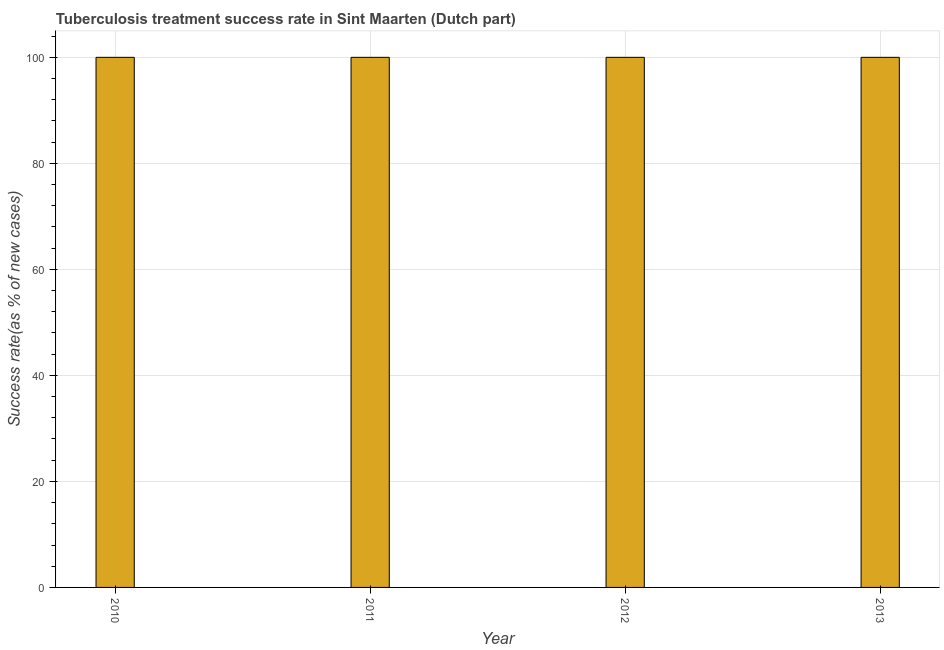Does the graph contain grids?
Offer a very short reply. Yes. What is the title of the graph?
Provide a succinct answer. Tuberculosis treatment success rate in Sint Maarten (Dutch part). What is the label or title of the Y-axis?
Keep it short and to the point. Success rate(as % of new cases). Across all years, what is the maximum tuberculosis treatment success rate?
Provide a short and direct response. 100. Across all years, what is the minimum tuberculosis treatment success rate?
Your answer should be very brief. 100. In which year was the tuberculosis treatment success rate minimum?
Provide a short and direct response. 2010. What is the difference between the tuberculosis treatment success rate in 2010 and 2011?
Your response must be concise. 0. What is the ratio of the tuberculosis treatment success rate in 2010 to that in 2011?
Keep it short and to the point. 1. What is the difference between the highest and the second highest tuberculosis treatment success rate?
Make the answer very short. 0. Is the sum of the tuberculosis treatment success rate in 2012 and 2013 greater than the maximum tuberculosis treatment success rate across all years?
Provide a succinct answer. Yes. How many years are there in the graph?
Offer a very short reply. 4. What is the difference between two consecutive major ticks on the Y-axis?
Your answer should be very brief. 20. Are the values on the major ticks of Y-axis written in scientific E-notation?
Your answer should be compact. No. What is the Success rate(as % of new cases) in 2011?
Offer a terse response. 100. What is the difference between the Success rate(as % of new cases) in 2010 and 2012?
Your answer should be compact. 0. What is the difference between the Success rate(as % of new cases) in 2012 and 2013?
Make the answer very short. 0. What is the ratio of the Success rate(as % of new cases) in 2010 to that in 2011?
Offer a terse response. 1. What is the ratio of the Success rate(as % of new cases) in 2011 to that in 2013?
Ensure brevity in your answer.  1. What is the ratio of the Success rate(as % of new cases) in 2012 to that in 2013?
Give a very brief answer. 1. 